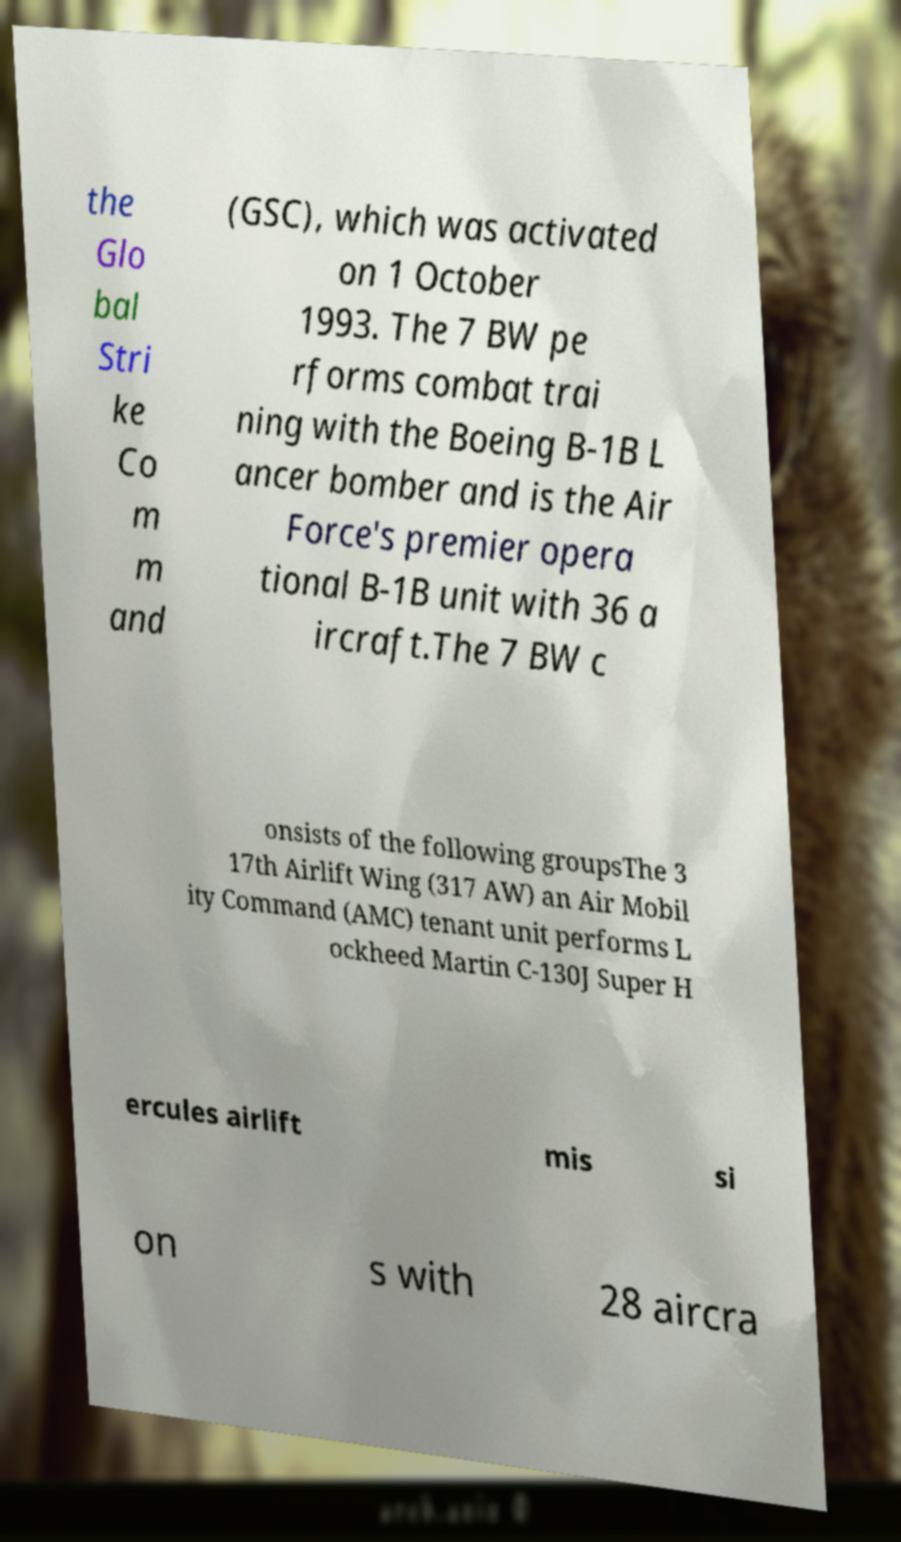There's text embedded in this image that I need extracted. Can you transcribe it verbatim? the Glo bal Stri ke Co m m and (GSC), which was activated on 1 October 1993. The 7 BW pe rforms combat trai ning with the Boeing B-1B L ancer bomber and is the Air Force's premier opera tional B-1B unit with 36 a ircraft.The 7 BW c onsists of the following groupsThe 3 17th Airlift Wing (317 AW) an Air Mobil ity Command (AMC) tenant unit performs L ockheed Martin C-130J Super H ercules airlift mis si on s with 28 aircra 